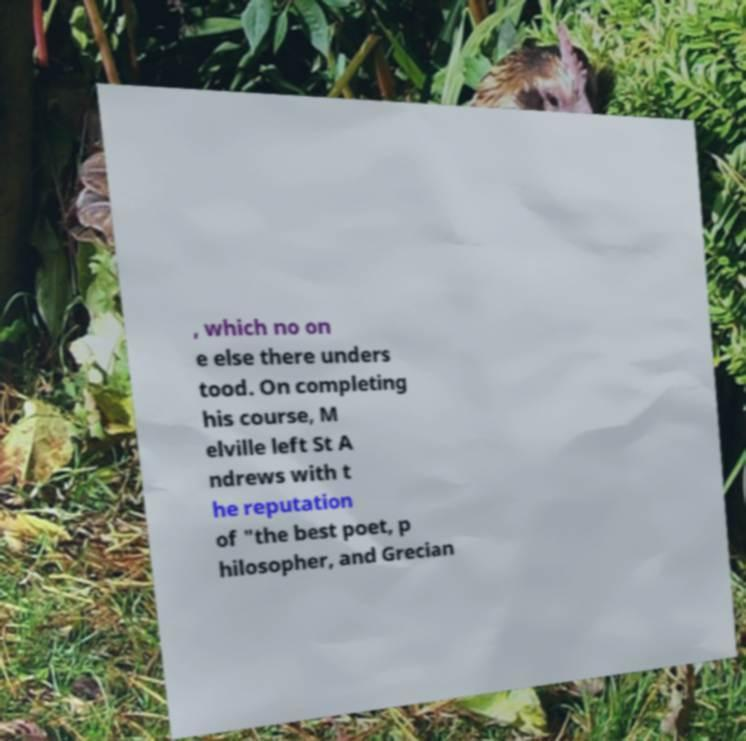For documentation purposes, I need the text within this image transcribed. Could you provide that? , which no on e else there unders tood. On completing his course, M elville left St A ndrews with t he reputation of "the best poet, p hilosopher, and Grecian 